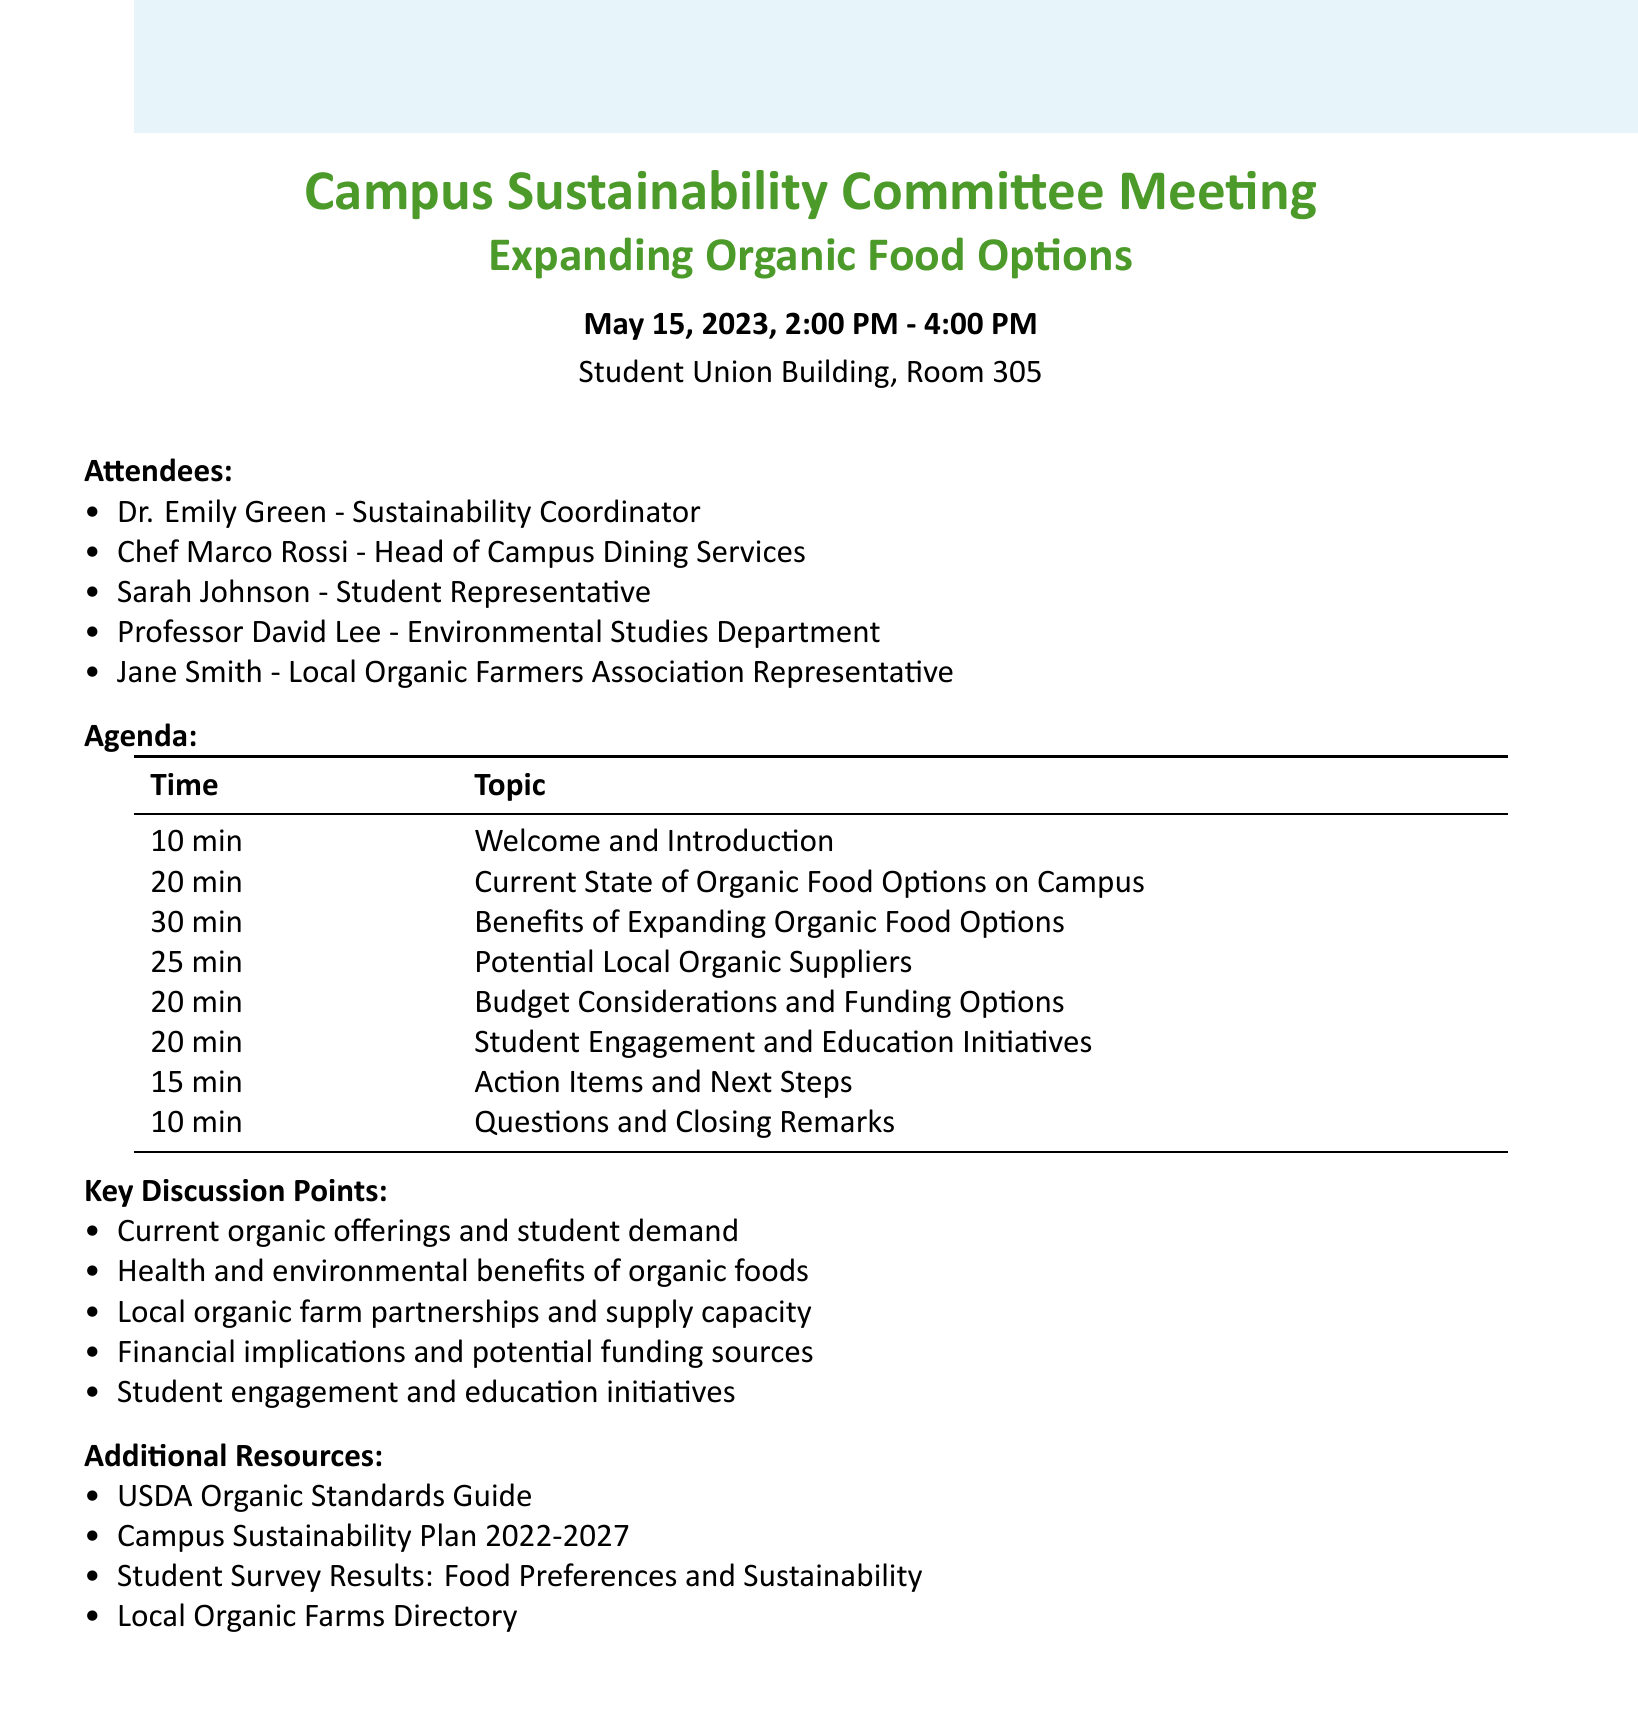what is the date and time of the meeting? The date and time are specified as May 15, 2023, from 2:00 PM to 4:00 PM.
Answer: May 15, 2023, 2:00 PM - 4:00 PM who is the head of campus dining services? The document lists Chef Marco Rossi as the Head of Campus Dining Services.
Answer: Chef Marco Rossi how long is the discussion on budget considerations? The agenda indicates that the budget considerations will take 20 minutes.
Answer: 20 minutes what is one key point discussed in the benefits of expanding organic food options? The key points include nutritional advantages of organic produce among others.
Answer: Nutritional advantages of organic produce which group is responsible for discussing potential local organic suppliers? Jane Smith from the Local Organic Farmers Association is responsible for this discussion.
Answer: Jane Smith - Local Organic Farmers Association Representative how many attendees are listed in the document? The document details five attendees at the meeting.
Answer: Five what is one activity mentioned to engage students? One of the proposed activities is cooking demonstrations featuring organic ingredients.
Answer: Cooking demonstrations featuring organic ingredients what is the location of the meeting? The meeting is set to take place in Student Union Building, Room 305.
Answer: Student Union Building, Room 305 what is the last agenda item in the meeting? The last agenda item is "Questions and Closing Remarks."
Answer: Questions and Closing Remarks 